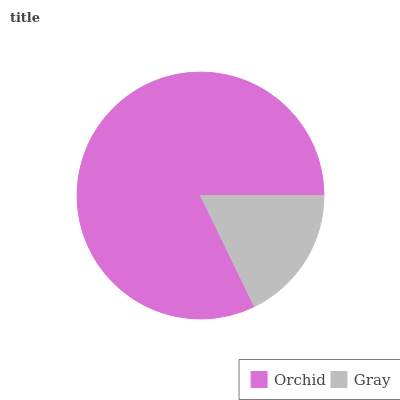Is Gray the minimum?
Answer yes or no. Yes. Is Orchid the maximum?
Answer yes or no. Yes. Is Gray the maximum?
Answer yes or no. No. Is Orchid greater than Gray?
Answer yes or no. Yes. Is Gray less than Orchid?
Answer yes or no. Yes. Is Gray greater than Orchid?
Answer yes or no. No. Is Orchid less than Gray?
Answer yes or no. No. Is Orchid the high median?
Answer yes or no. Yes. Is Gray the low median?
Answer yes or no. Yes. Is Gray the high median?
Answer yes or no. No. Is Orchid the low median?
Answer yes or no. No. 